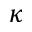<formula> <loc_0><loc_0><loc_500><loc_500>\kappa</formula> 